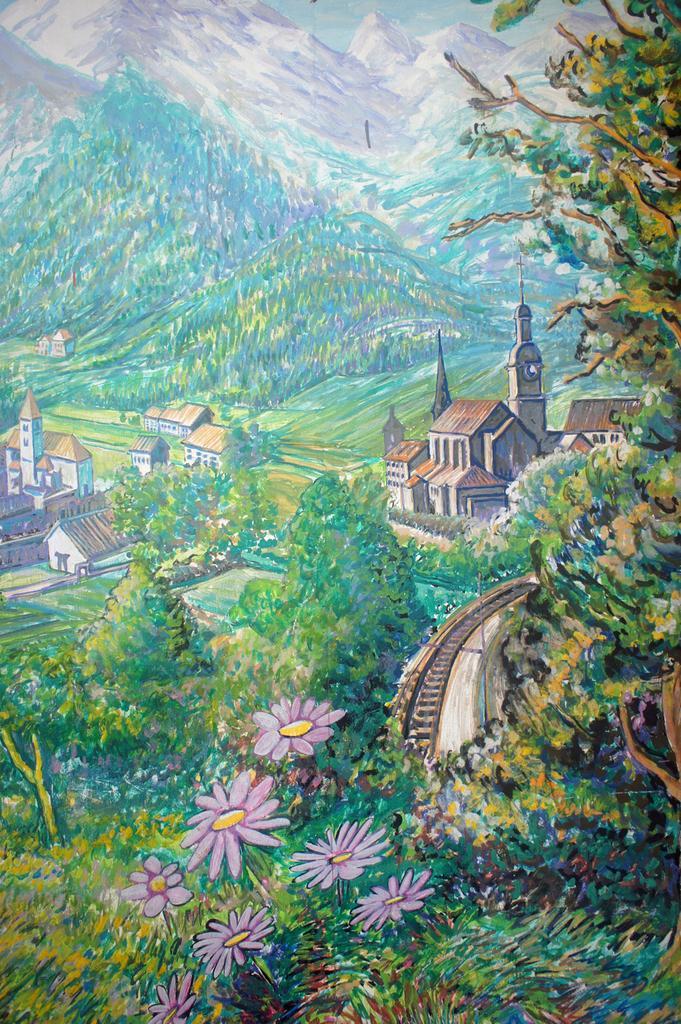Could you give a brief overview of what you see in this image? In this image there is a painting of trees, flowers, plants, buildings, mountains and there is a railway track, in the background there is the sky. 